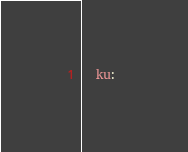<code> <loc_0><loc_0><loc_500><loc_500><_YAML_>  ku: 
</code> 